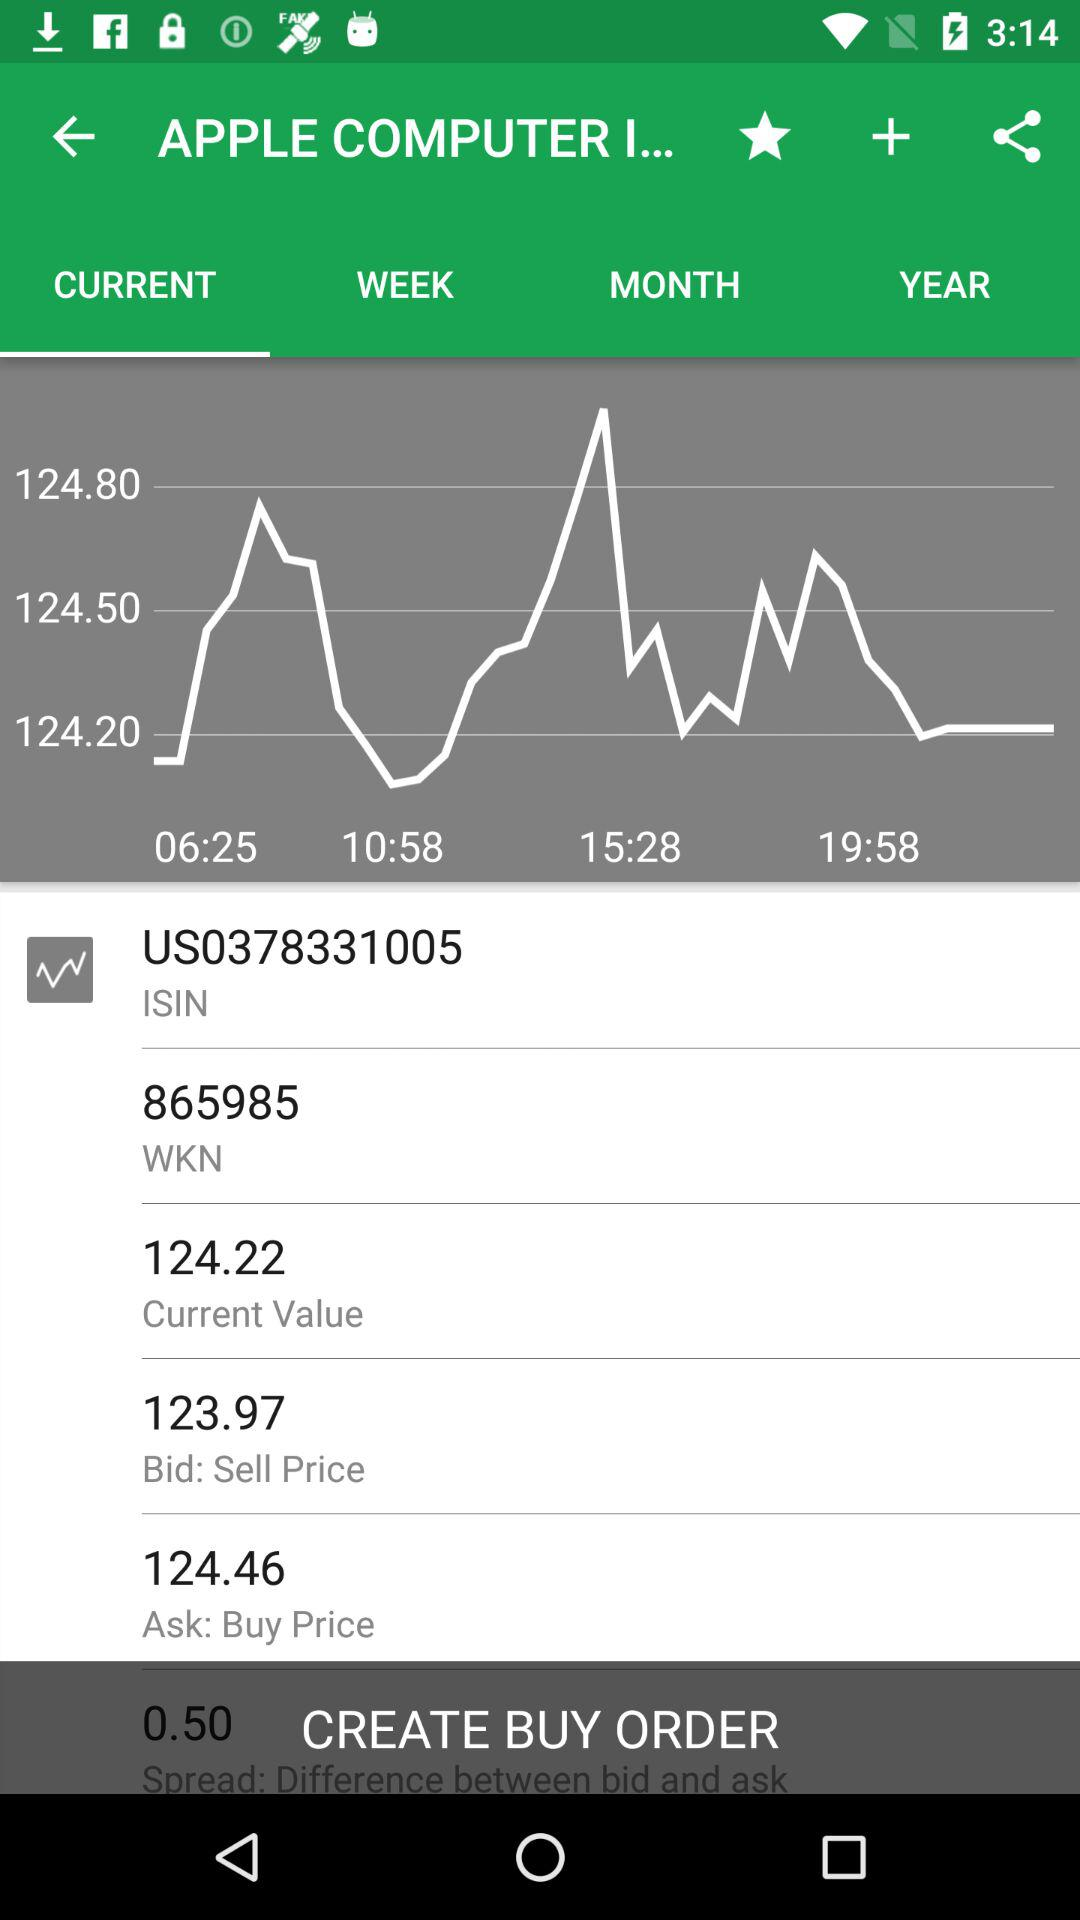What is the WKN number? The WKN number is 865985. 